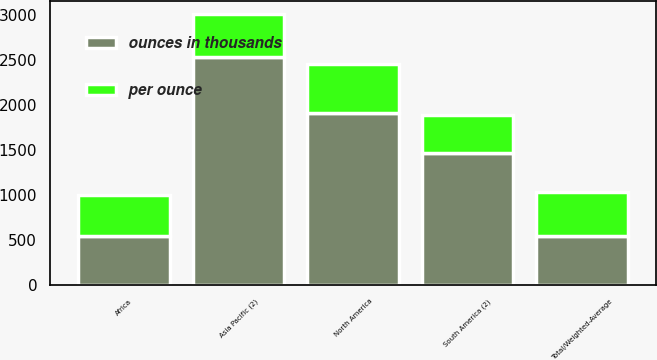<chart> <loc_0><loc_0><loc_500><loc_500><stacked_bar_chart><ecel><fcel>North America<fcel>South America (2)<fcel>Asia Pacific (2)<fcel>Africa<fcel>Total/Weighted-Average<nl><fcel>ounces in thousands<fcel>1909<fcel>1462<fcel>2535<fcel>545<fcel>545<nl><fcel>per ounce<fcel>551<fcel>431<fcel>474<fcel>450<fcel>485<nl></chart> 